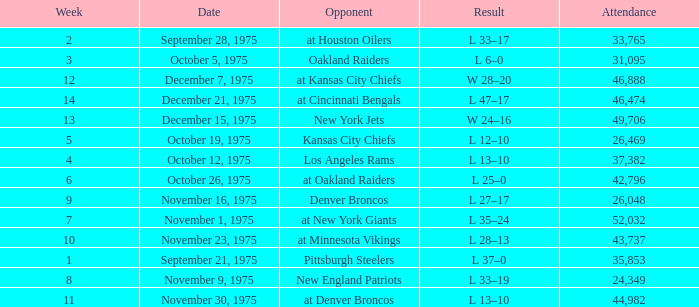What is the highest Week when the opponent was the los angeles rams, with more than 37,382 in Attendance? None. 